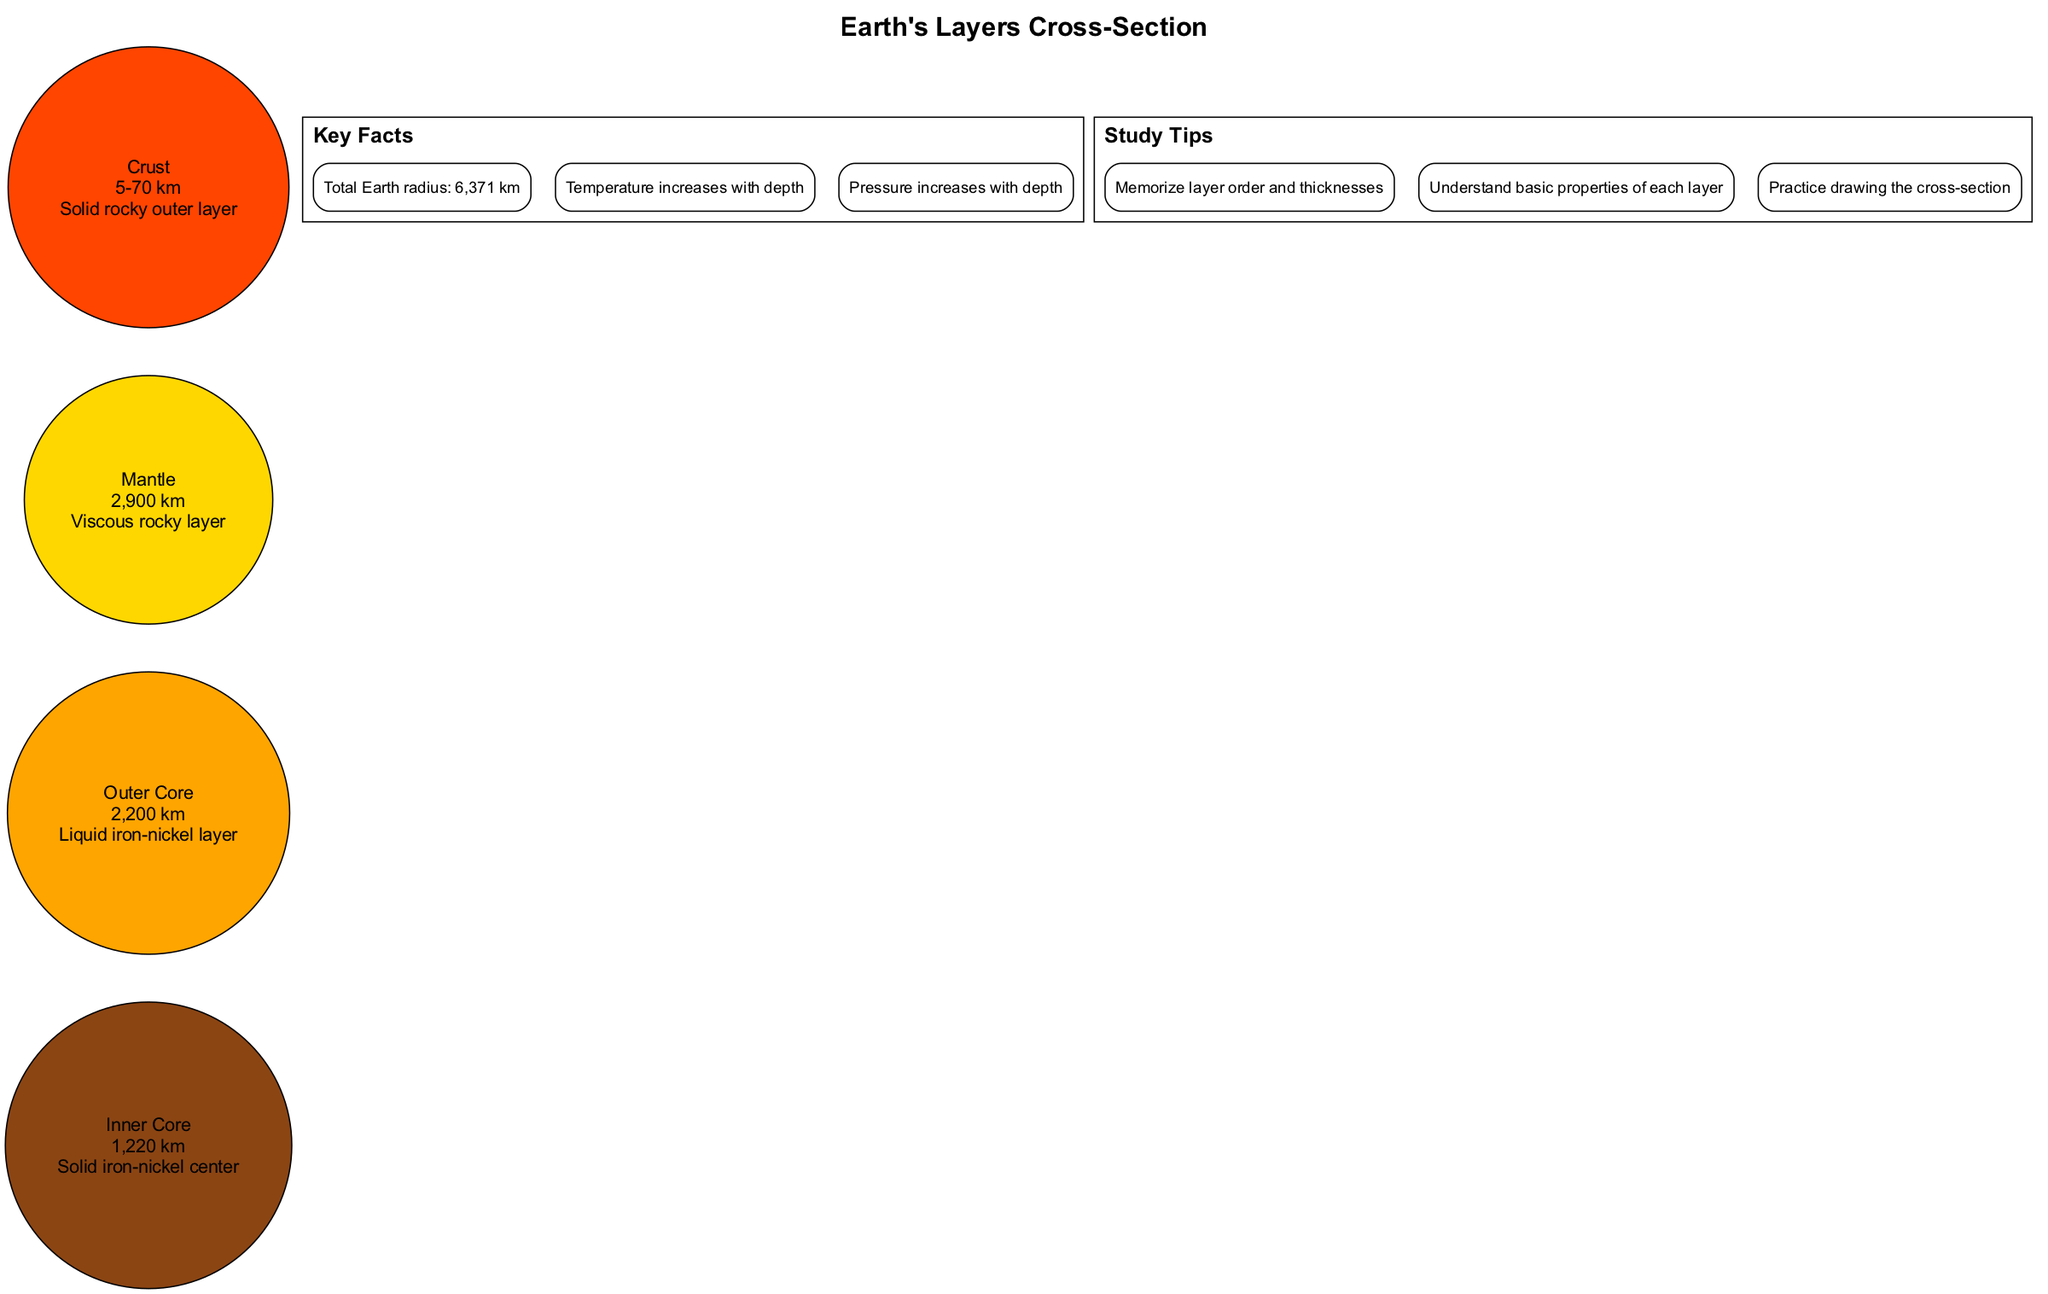What is the thickness of the crust? The diagram specifies the thickness of the crust as "5-70 km" and displays this information directly as part of the properties listed for the crust layer.
Answer: 5-70 km What is the state of the outer core? The diagram indicates that the outer core is a "Liquid iron-nickel layer," which is a part of the description provided for the outer core.
Answer: Liquid iron-nickel Which layer is the thickest? By looking at the thickness values listed in the diagram, the mantle's thickness is "2,900 km," which is greater than the thickness of the other layers.
Answer: Mantle How many layers are there in total? The diagram lists four layers: crust, mantle, outer core, and inner core, which can be counted directly from the information presented.
Answer: 4 What is the relationship between temperature and depth according to the key facts? The key facts state that "Temperature increases with depth," indicating a direct correlation between deeper layers and higher temperatures.
Answer: Increases What layer comes directly above the outer core? The outer core is shown below the mantle as per the diagram's structure, which follows a top-to-bottom layering of Earth’s layers.
Answer: Mantle What is the approximate thickness of the inner core? The diagram reveals that the thickness of the inner core is "1,220 km," which is stated explicitly in the layer descriptions.
Answer: 1,220 km Explain why the crust varies in thickness. The crust varies in thickness due to its formation and the geological processes that shape it differentially across locations, as indicated by its "5-70 km" thickness.
Answer: Varied geological processes What does the thickness of the outer core indicate about its density compared to other layers? The thickness of "2,200 km" and that it is a liquid layer suggest that it holds more volume but is less dense than the solid inner core and crust.
Answer: Less dense than inner core 